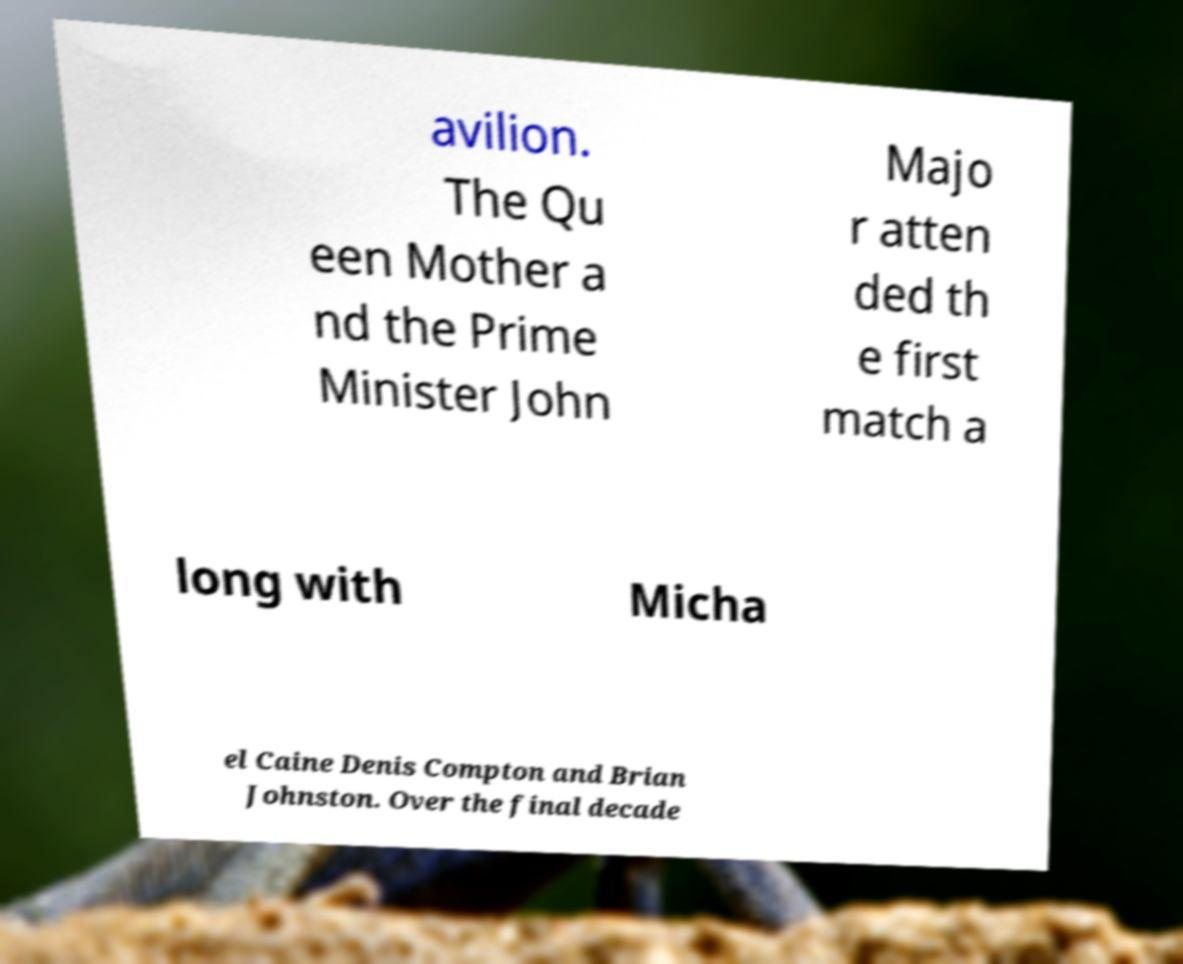I need the written content from this picture converted into text. Can you do that? avilion. The Qu een Mother a nd the Prime Minister John Majo r atten ded th e first match a long with Micha el Caine Denis Compton and Brian Johnston. Over the final decade 